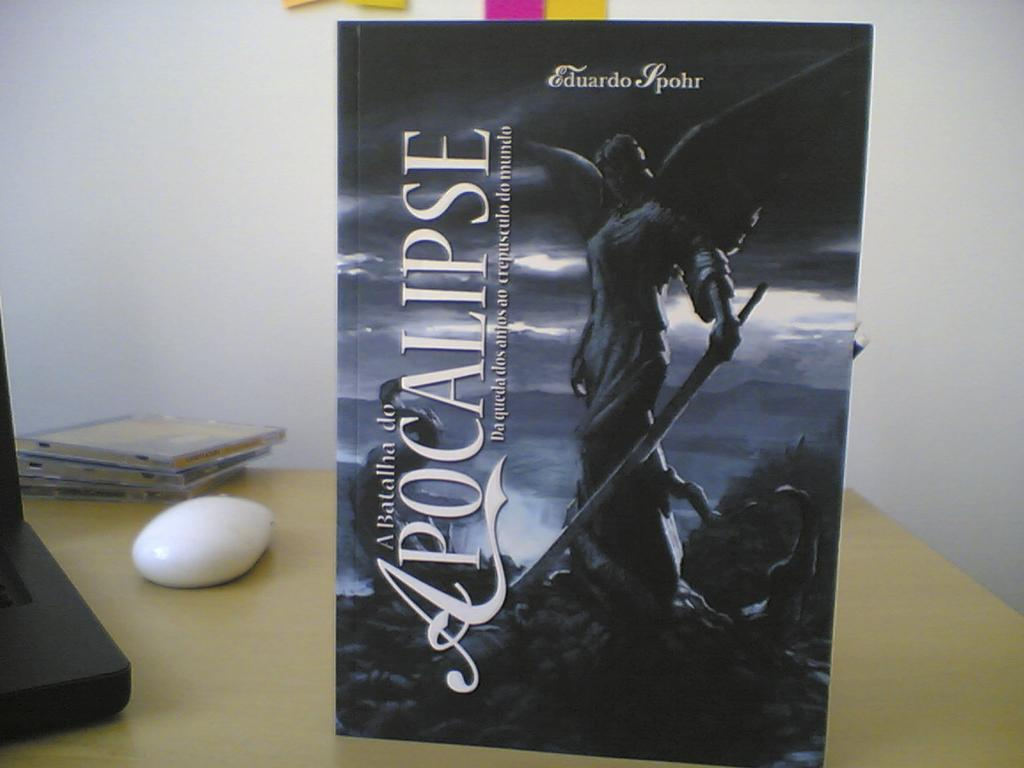<image>
Present a compact description of the photo's key features. a book that is about the Apocalypse with a statue on it 